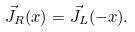Convert formula to latex. <formula><loc_0><loc_0><loc_500><loc_500>\vec { J } _ { R } ( x ) = \vec { J } _ { L } ( - x ) .</formula> 